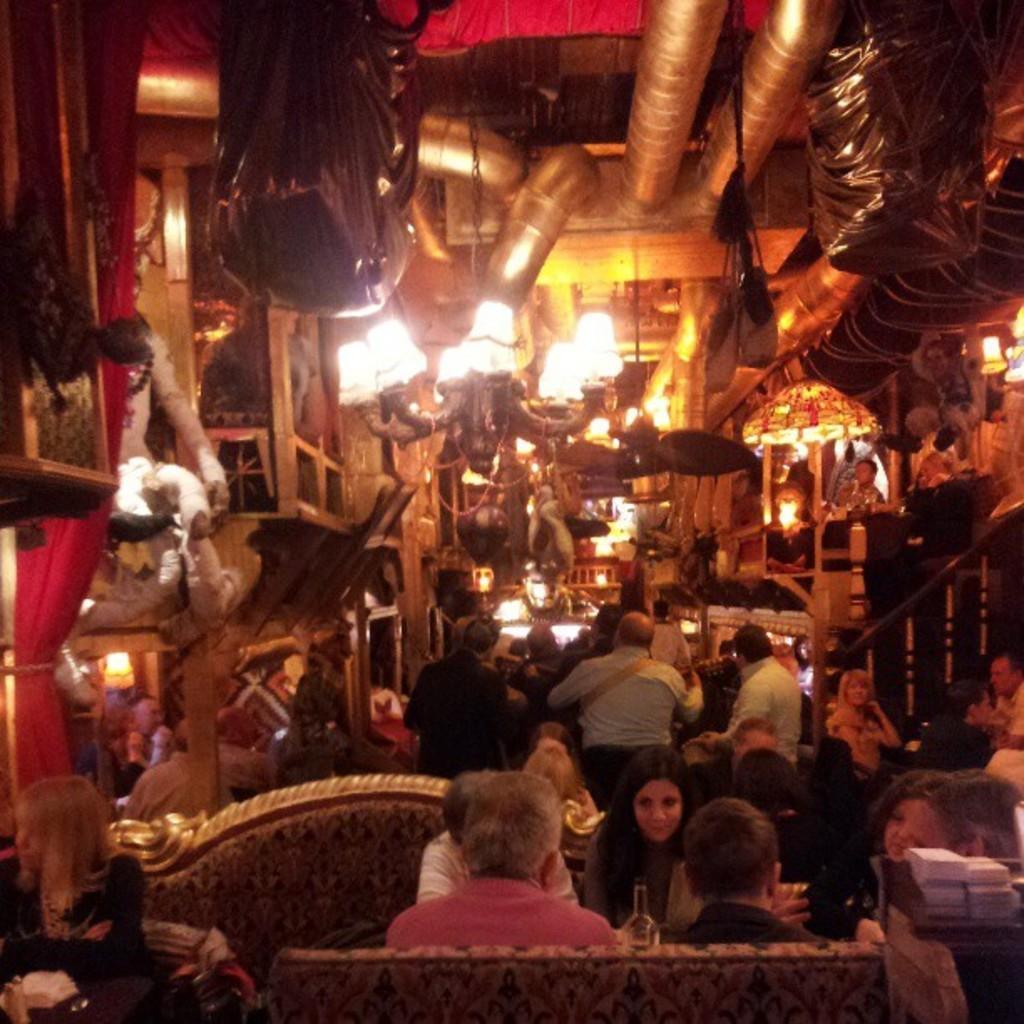Describe this image in one or two sentences. In this picture we can see a few people sitting on the chair. There are some people standing. We can see a few objects on the right and left side of the image. There is a curtain and a rope on the left side. We can see some objects on top and in the background. 